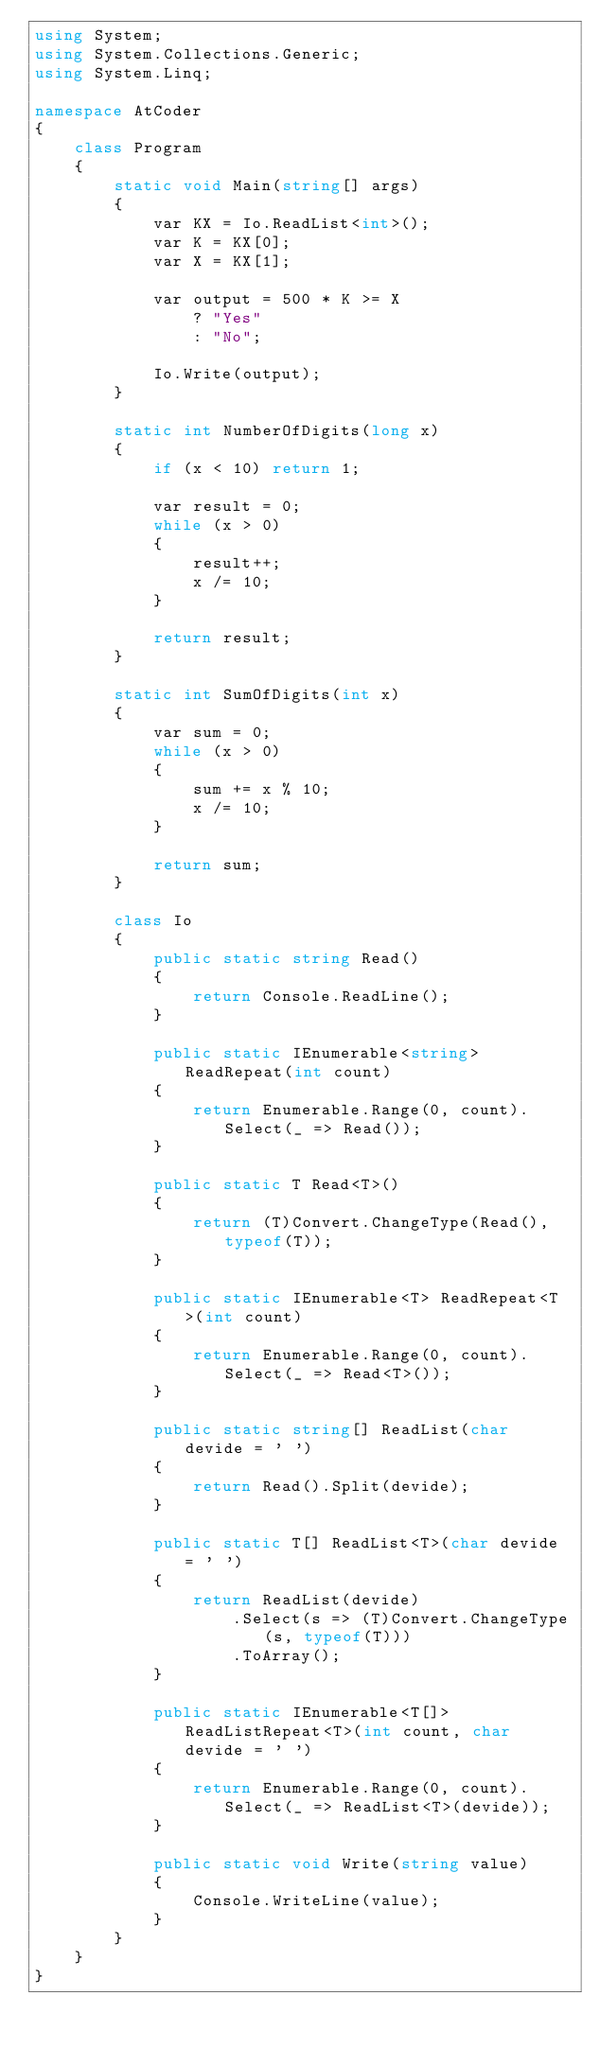Convert code to text. <code><loc_0><loc_0><loc_500><loc_500><_C#_>using System;
using System.Collections.Generic;
using System.Linq;

namespace AtCoder
{
    class Program
    {
        static void Main(string[] args)
        {
            var KX = Io.ReadList<int>();
            var K = KX[0];
            var X = KX[1];

            var output = 500 * K >= X
                ? "Yes"
                : "No";

            Io.Write(output);
        }

        static int NumberOfDigits(long x)
        {
            if (x < 10) return 1;

            var result = 0;
            while (x > 0)
            {
                result++;
                x /= 10;
            }

            return result;
        }

        static int SumOfDigits(int x)
        {
            var sum = 0;
            while (x > 0)
            {
                sum += x % 10;
                x /= 10;
            }

            return sum;
        }

        class Io
        {
            public static string Read()
            {
                return Console.ReadLine();
            }

            public static IEnumerable<string> ReadRepeat(int count)
            {
                return Enumerable.Range(0, count).Select(_ => Read());
            }

            public static T Read<T>()
            {
                return (T)Convert.ChangeType(Read(), typeof(T));
            }

            public static IEnumerable<T> ReadRepeat<T>(int count)
            {
                return Enumerable.Range(0, count).Select(_ => Read<T>());
            }

            public static string[] ReadList(char devide = ' ')
            {
                return Read().Split(devide);
            }

            public static T[] ReadList<T>(char devide = ' ')
            {
                return ReadList(devide)
                    .Select(s => (T)Convert.ChangeType(s, typeof(T)))
                    .ToArray();
            }

            public static IEnumerable<T[]> ReadListRepeat<T>(int count, char devide = ' ')
            {
                return Enumerable.Range(0, count).Select(_ => ReadList<T>(devide));
            }

            public static void Write(string value)
            {
                Console.WriteLine(value);
            }
        }
    }
}
</code> 